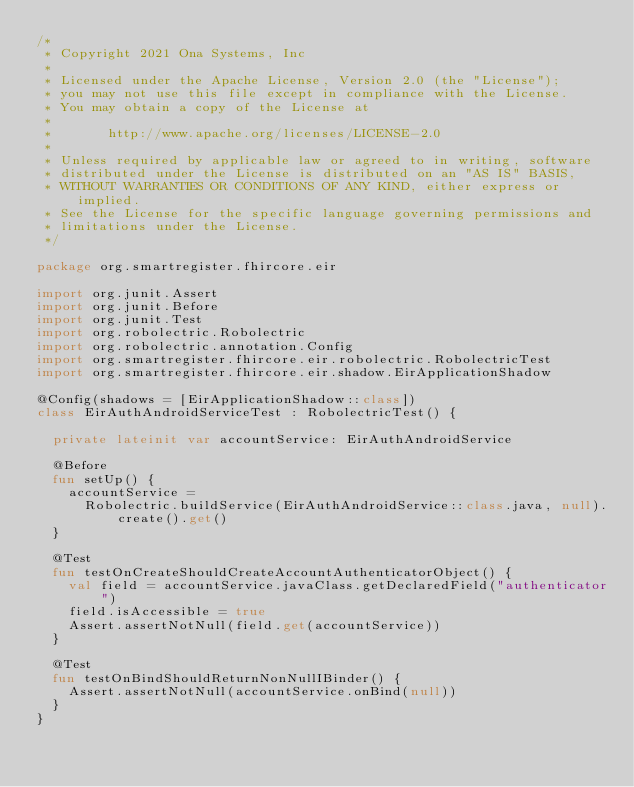<code> <loc_0><loc_0><loc_500><loc_500><_Kotlin_>/*
 * Copyright 2021 Ona Systems, Inc
 *
 * Licensed under the Apache License, Version 2.0 (the "License");
 * you may not use this file except in compliance with the License.
 * You may obtain a copy of the License at
 *
 *       http://www.apache.org/licenses/LICENSE-2.0
 *
 * Unless required by applicable law or agreed to in writing, software
 * distributed under the License is distributed on an "AS IS" BASIS,
 * WITHOUT WARRANTIES OR CONDITIONS OF ANY KIND, either express or implied.
 * See the License for the specific language governing permissions and
 * limitations under the License.
 */

package org.smartregister.fhircore.eir

import org.junit.Assert
import org.junit.Before
import org.junit.Test
import org.robolectric.Robolectric
import org.robolectric.annotation.Config
import org.smartregister.fhircore.eir.robolectric.RobolectricTest
import org.smartregister.fhircore.eir.shadow.EirApplicationShadow

@Config(shadows = [EirApplicationShadow::class])
class EirAuthAndroidServiceTest : RobolectricTest() {

  private lateinit var accountService: EirAuthAndroidService

  @Before
  fun setUp() {
    accountService =
      Robolectric.buildService(EirAuthAndroidService::class.java, null).create().get()
  }

  @Test
  fun testOnCreateShouldCreateAccountAuthenticatorObject() {
    val field = accountService.javaClass.getDeclaredField("authenticator")
    field.isAccessible = true
    Assert.assertNotNull(field.get(accountService))
  }

  @Test
  fun testOnBindShouldReturnNonNullIBinder() {
    Assert.assertNotNull(accountService.onBind(null))
  }
}
</code> 